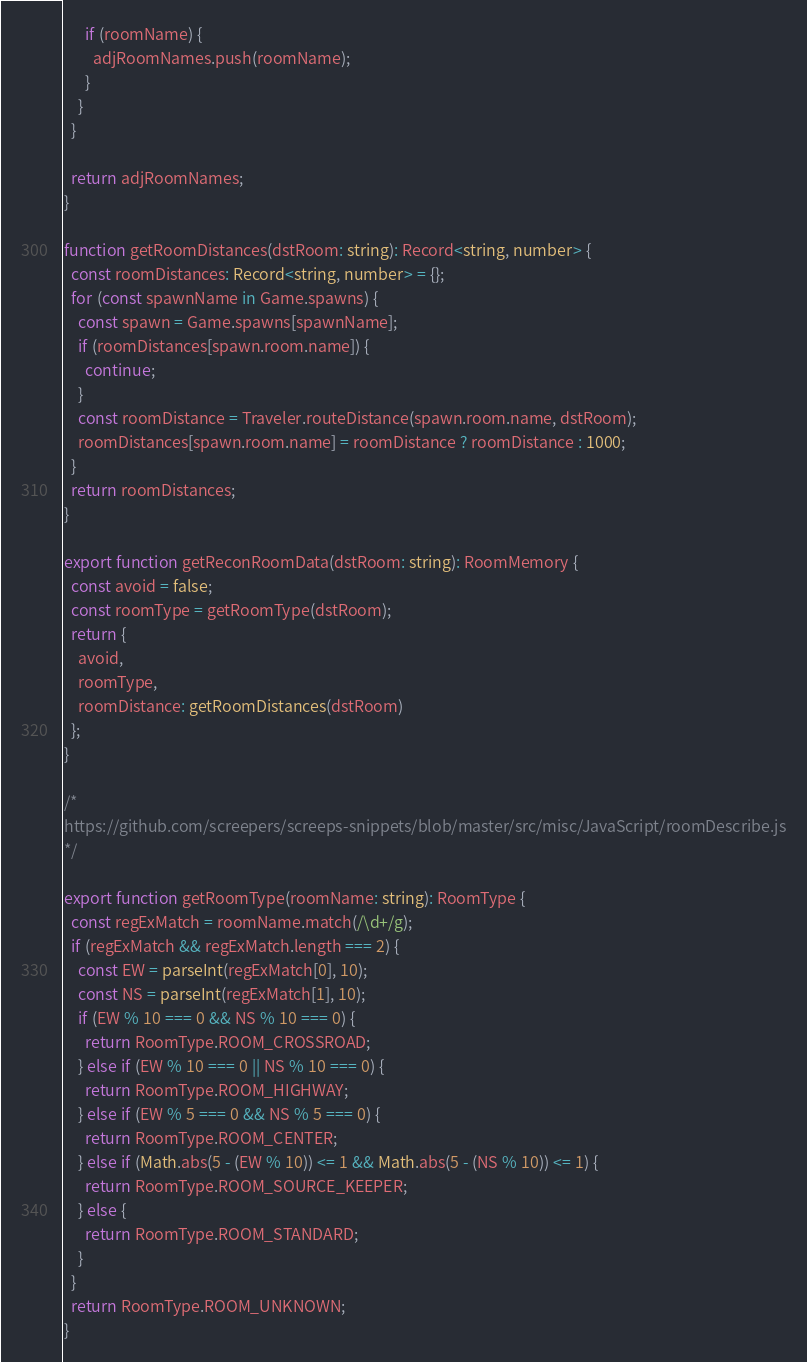Convert code to text. <code><loc_0><loc_0><loc_500><loc_500><_TypeScript_>      if (roomName) {
        adjRoomNames.push(roomName);
      }
    }
  }

  return adjRoomNames;
}

function getRoomDistances(dstRoom: string): Record<string, number> {
  const roomDistances: Record<string, number> = {};
  for (const spawnName in Game.spawns) {
    const spawn = Game.spawns[spawnName];
    if (roomDistances[spawn.room.name]) {
      continue;
    }
    const roomDistance = Traveler.routeDistance(spawn.room.name, dstRoom);
    roomDistances[spawn.room.name] = roomDistance ? roomDistance : 1000;
  }
  return roomDistances;
}

export function getReconRoomData(dstRoom: string): RoomMemory {
  const avoid = false;
  const roomType = getRoomType(dstRoom);
  return {
    avoid,
    roomType,
    roomDistance: getRoomDistances(dstRoom)
  };
}

/*
https://github.com/screepers/screeps-snippets/blob/master/src/misc/JavaScript/roomDescribe.js
*/

export function getRoomType(roomName: string): RoomType {
  const regExMatch = roomName.match(/\d+/g);
  if (regExMatch && regExMatch.length === 2) {
    const EW = parseInt(regExMatch[0], 10);
    const NS = parseInt(regExMatch[1], 10);
    if (EW % 10 === 0 && NS % 10 === 0) {
      return RoomType.ROOM_CROSSROAD;
    } else if (EW % 10 === 0 || NS % 10 === 0) {
      return RoomType.ROOM_HIGHWAY;
    } else if (EW % 5 === 0 && NS % 5 === 0) {
      return RoomType.ROOM_CENTER;
    } else if (Math.abs(5 - (EW % 10)) <= 1 && Math.abs(5 - (NS % 10)) <= 1) {
      return RoomType.ROOM_SOURCE_KEEPER;
    } else {
      return RoomType.ROOM_STANDARD;
    }
  }
  return RoomType.ROOM_UNKNOWN;
}
</code> 